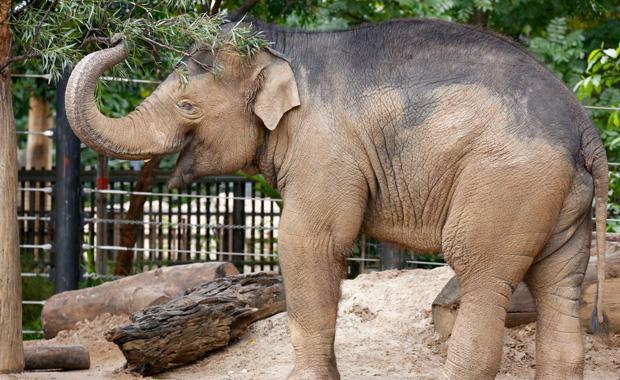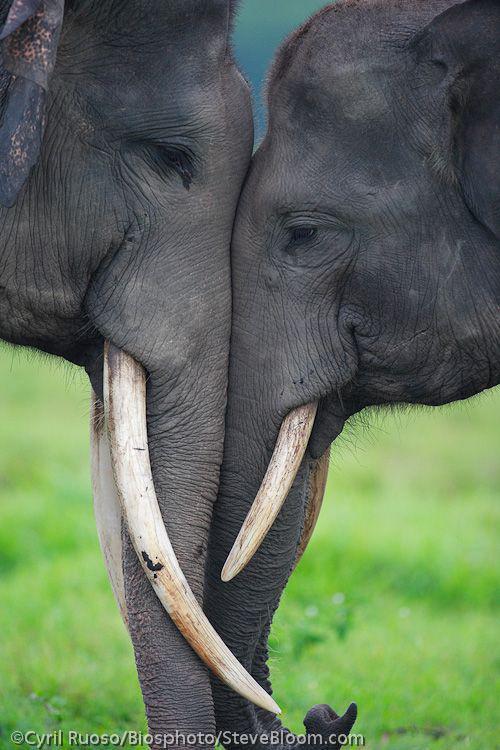The first image is the image on the left, the second image is the image on the right. Assess this claim about the two images: "Two elephants are butting heads in one of the images.". Correct or not? Answer yes or no. Yes. The first image is the image on the left, the second image is the image on the right. Considering the images on both sides, is "An image shows two elephants face-to-face with their faces touching." valid? Answer yes or no. Yes. 